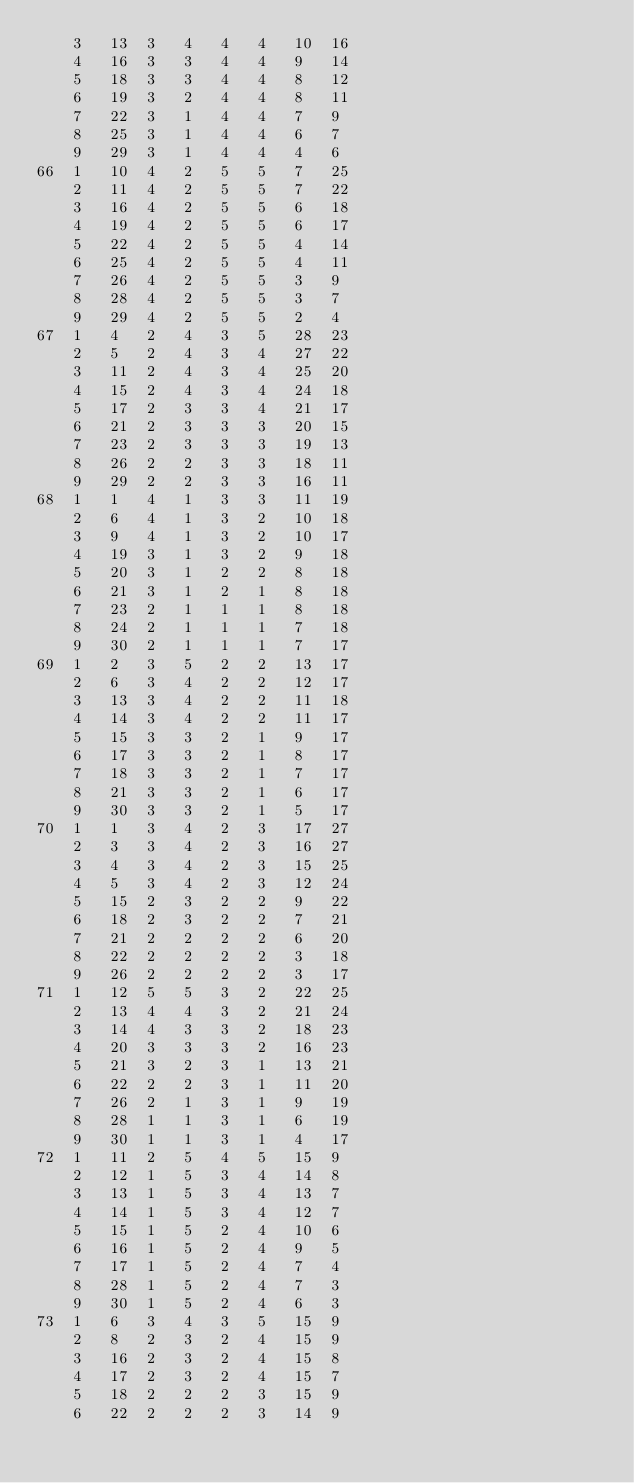<code> <loc_0><loc_0><loc_500><loc_500><_ObjectiveC_>	3	13	3	4	4	4	10	16	
	4	16	3	3	4	4	9	14	
	5	18	3	3	4	4	8	12	
	6	19	3	2	4	4	8	11	
	7	22	3	1	4	4	7	9	
	8	25	3	1	4	4	6	7	
	9	29	3	1	4	4	4	6	
66	1	10	4	2	5	5	7	25	
	2	11	4	2	5	5	7	22	
	3	16	4	2	5	5	6	18	
	4	19	4	2	5	5	6	17	
	5	22	4	2	5	5	4	14	
	6	25	4	2	5	5	4	11	
	7	26	4	2	5	5	3	9	
	8	28	4	2	5	5	3	7	
	9	29	4	2	5	5	2	4	
67	1	4	2	4	3	5	28	23	
	2	5	2	4	3	4	27	22	
	3	11	2	4	3	4	25	20	
	4	15	2	4	3	4	24	18	
	5	17	2	3	3	4	21	17	
	6	21	2	3	3	3	20	15	
	7	23	2	3	3	3	19	13	
	8	26	2	2	3	3	18	11	
	9	29	2	2	3	3	16	11	
68	1	1	4	1	3	3	11	19	
	2	6	4	1	3	2	10	18	
	3	9	4	1	3	2	10	17	
	4	19	3	1	3	2	9	18	
	5	20	3	1	2	2	8	18	
	6	21	3	1	2	1	8	18	
	7	23	2	1	1	1	8	18	
	8	24	2	1	1	1	7	18	
	9	30	2	1	1	1	7	17	
69	1	2	3	5	2	2	13	17	
	2	6	3	4	2	2	12	17	
	3	13	3	4	2	2	11	18	
	4	14	3	4	2	2	11	17	
	5	15	3	3	2	1	9	17	
	6	17	3	3	2	1	8	17	
	7	18	3	3	2	1	7	17	
	8	21	3	3	2	1	6	17	
	9	30	3	3	2	1	5	17	
70	1	1	3	4	2	3	17	27	
	2	3	3	4	2	3	16	27	
	3	4	3	4	2	3	15	25	
	4	5	3	4	2	3	12	24	
	5	15	2	3	2	2	9	22	
	6	18	2	3	2	2	7	21	
	7	21	2	2	2	2	6	20	
	8	22	2	2	2	2	3	18	
	9	26	2	2	2	2	3	17	
71	1	12	5	5	3	2	22	25	
	2	13	4	4	3	2	21	24	
	3	14	4	3	3	2	18	23	
	4	20	3	3	3	2	16	23	
	5	21	3	2	3	1	13	21	
	6	22	2	2	3	1	11	20	
	7	26	2	1	3	1	9	19	
	8	28	1	1	3	1	6	19	
	9	30	1	1	3	1	4	17	
72	1	11	2	5	4	5	15	9	
	2	12	1	5	3	4	14	8	
	3	13	1	5	3	4	13	7	
	4	14	1	5	3	4	12	7	
	5	15	1	5	2	4	10	6	
	6	16	1	5	2	4	9	5	
	7	17	1	5	2	4	7	4	
	8	28	1	5	2	4	7	3	
	9	30	1	5	2	4	6	3	
73	1	6	3	4	3	5	15	9	
	2	8	2	3	2	4	15	9	
	3	16	2	3	2	4	15	8	
	4	17	2	3	2	4	15	7	
	5	18	2	2	2	3	15	9	
	6	22	2	2	2	3	14	9	</code> 